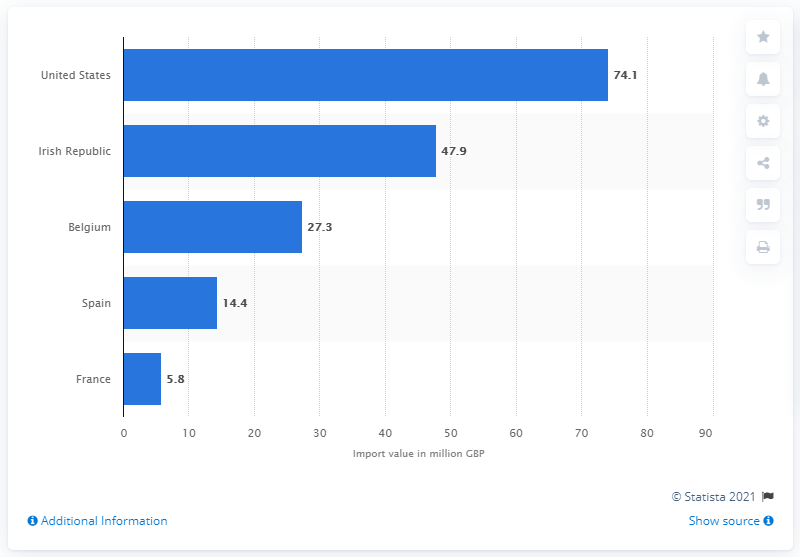Indicate a few pertinent items in this graphic. In 2020, the UK imported 74.1 million liters of whiskey from the United States. 